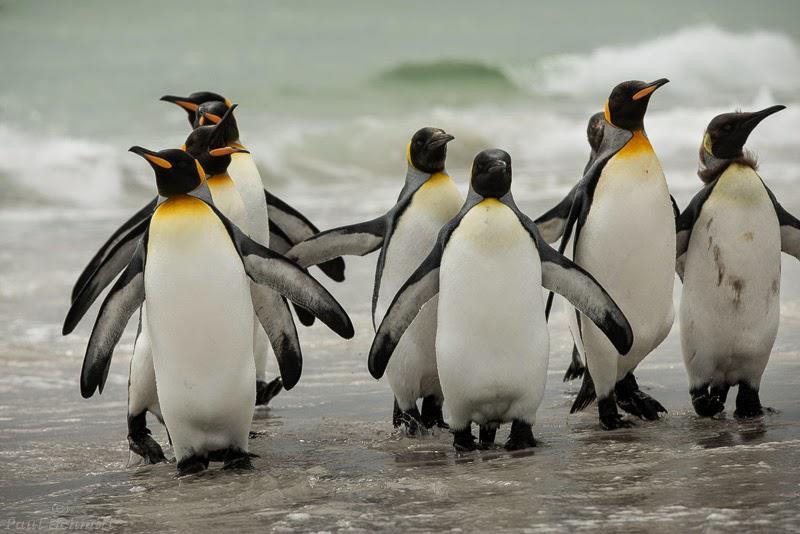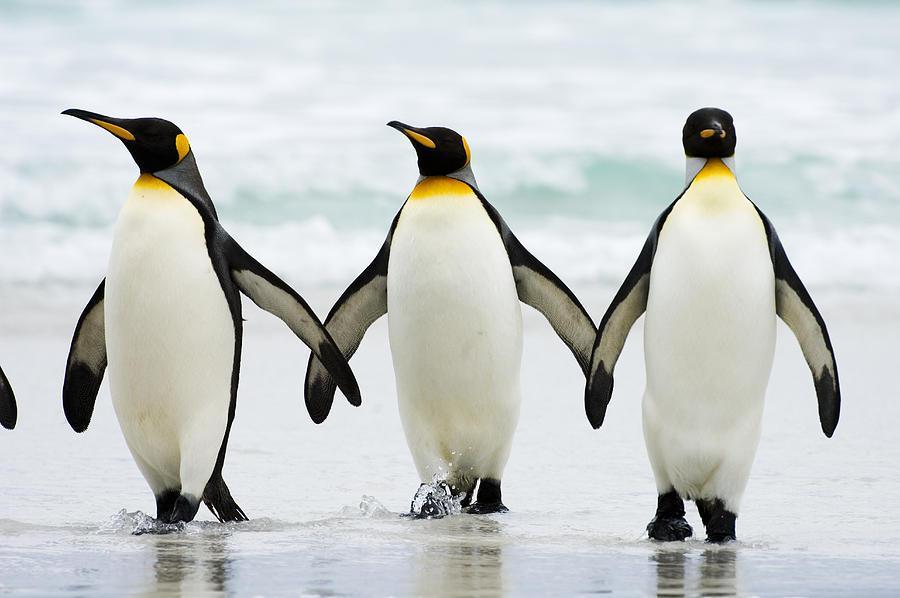The first image is the image on the left, the second image is the image on the right. Given the left and right images, does the statement "Images include penguins walking through water." hold true? Answer yes or no. Yes. The first image is the image on the left, the second image is the image on the right. Analyze the images presented: Is the assertion "The penguins in at least one of the images are walking through the waves." valid? Answer yes or no. Yes. 